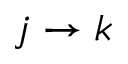<formula> <loc_0><loc_0><loc_500><loc_500>j \to k</formula> 